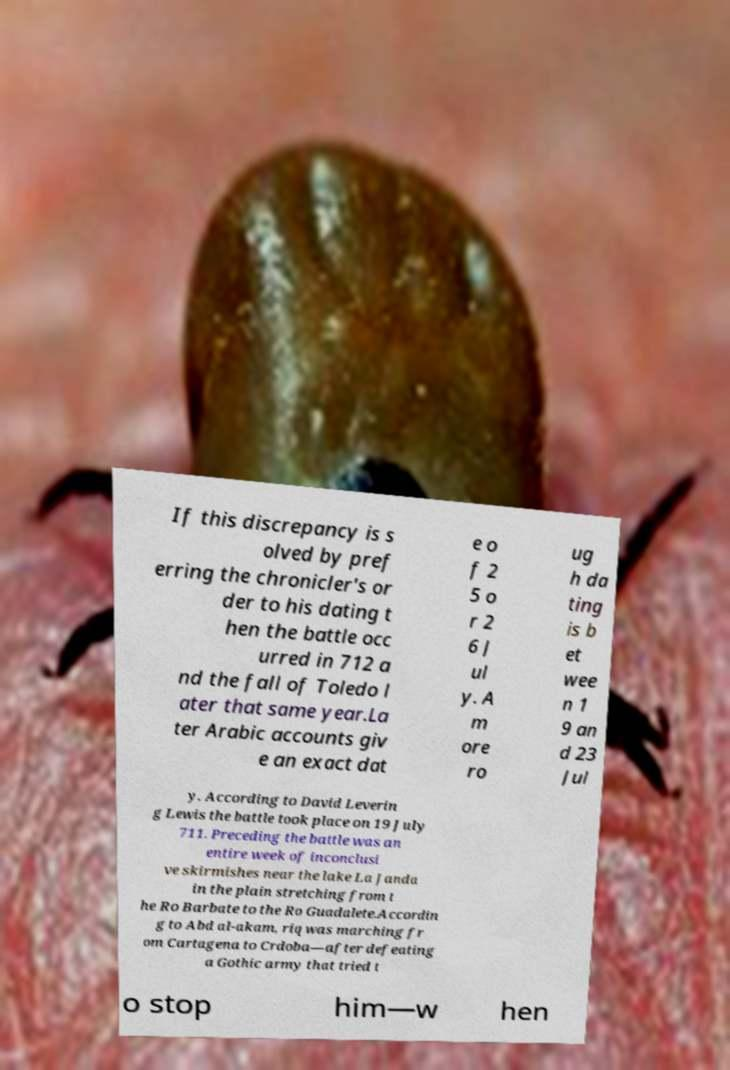Could you extract and type out the text from this image? If this discrepancy is s olved by pref erring the chronicler's or der to his dating t hen the battle occ urred in 712 a nd the fall of Toledo l ater that same year.La ter Arabic accounts giv e an exact dat e o f 2 5 o r 2 6 J ul y. A m ore ro ug h da ting is b et wee n 1 9 an d 23 Jul y. According to David Leverin g Lewis the battle took place on 19 July 711. Preceding the battle was an entire week of inconclusi ve skirmishes near the lake La Janda in the plain stretching from t he Ro Barbate to the Ro Guadalete.Accordin g to Abd al-akam, riq was marching fr om Cartagena to Crdoba—after defeating a Gothic army that tried t o stop him—w hen 